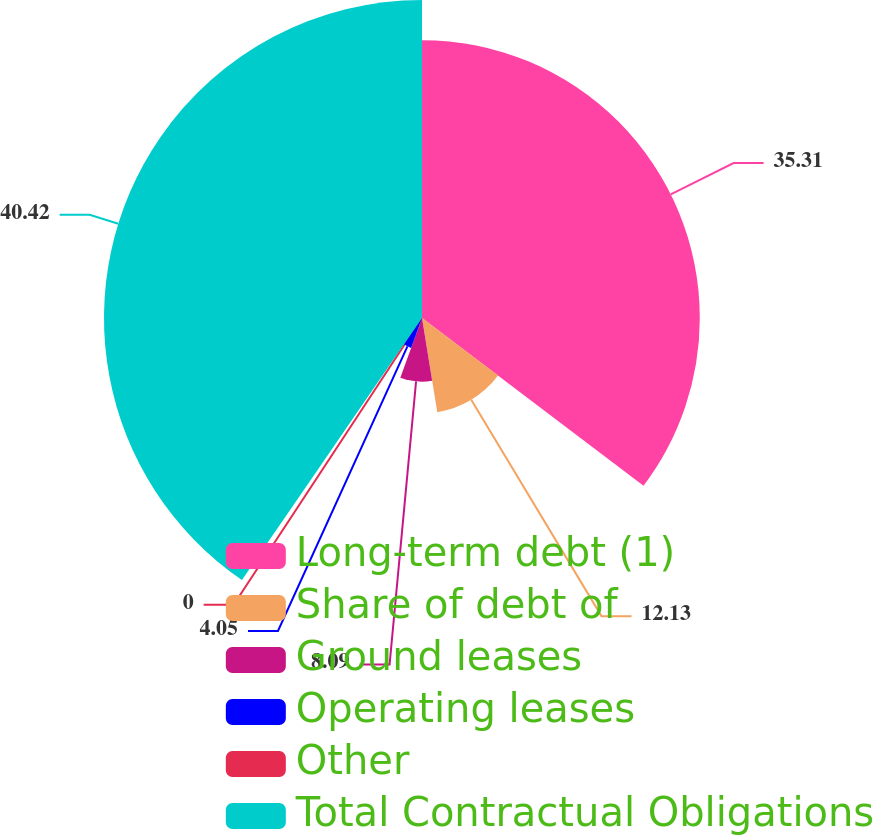Convert chart to OTSL. <chart><loc_0><loc_0><loc_500><loc_500><pie_chart><fcel>Long-term debt (1)<fcel>Share of debt of<fcel>Ground leases<fcel>Operating leases<fcel>Other<fcel>Total Contractual Obligations<nl><fcel>35.31%<fcel>12.13%<fcel>8.09%<fcel>4.05%<fcel>0.0%<fcel>40.42%<nl></chart> 